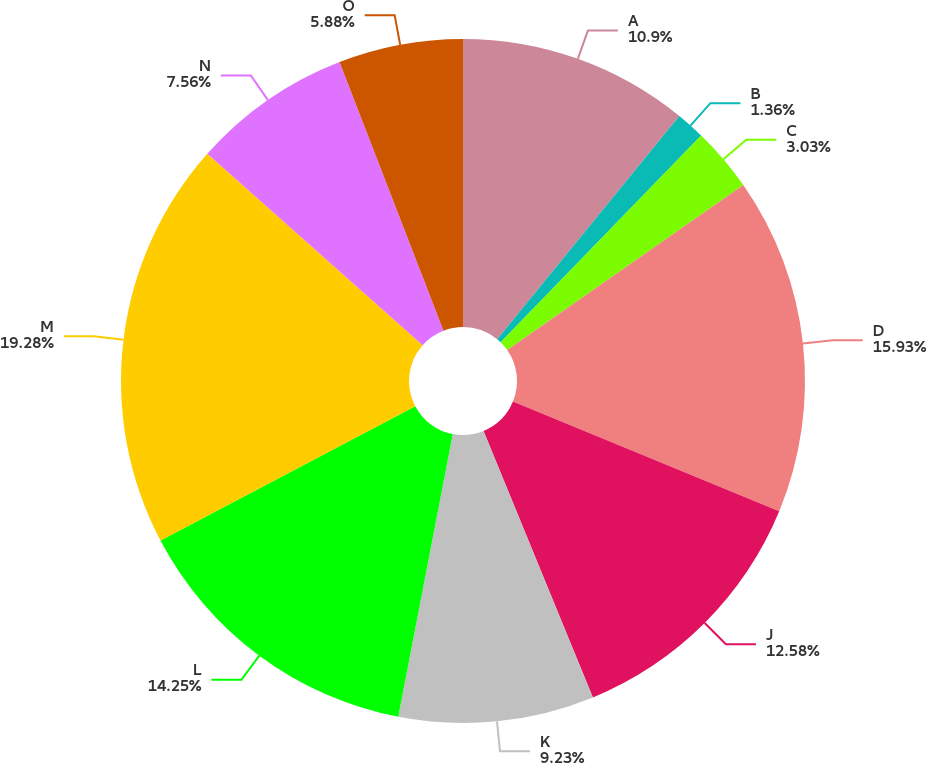Convert chart to OTSL. <chart><loc_0><loc_0><loc_500><loc_500><pie_chart><fcel>A<fcel>B<fcel>C<fcel>D<fcel>J<fcel>K<fcel>L<fcel>M<fcel>N<fcel>O<nl><fcel>10.9%<fcel>1.36%<fcel>3.03%<fcel>15.93%<fcel>12.58%<fcel>9.23%<fcel>14.25%<fcel>19.28%<fcel>7.56%<fcel>5.88%<nl></chart> 